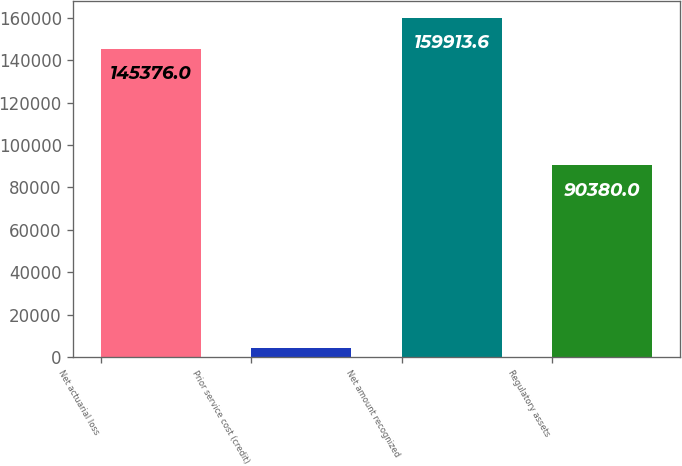Convert chart. <chart><loc_0><loc_0><loc_500><loc_500><bar_chart><fcel>Net actuarial loss<fcel>Prior service cost (credit)<fcel>Net amount recognized<fcel>Regulatory assets<nl><fcel>145376<fcel>4418<fcel>159914<fcel>90380<nl></chart> 